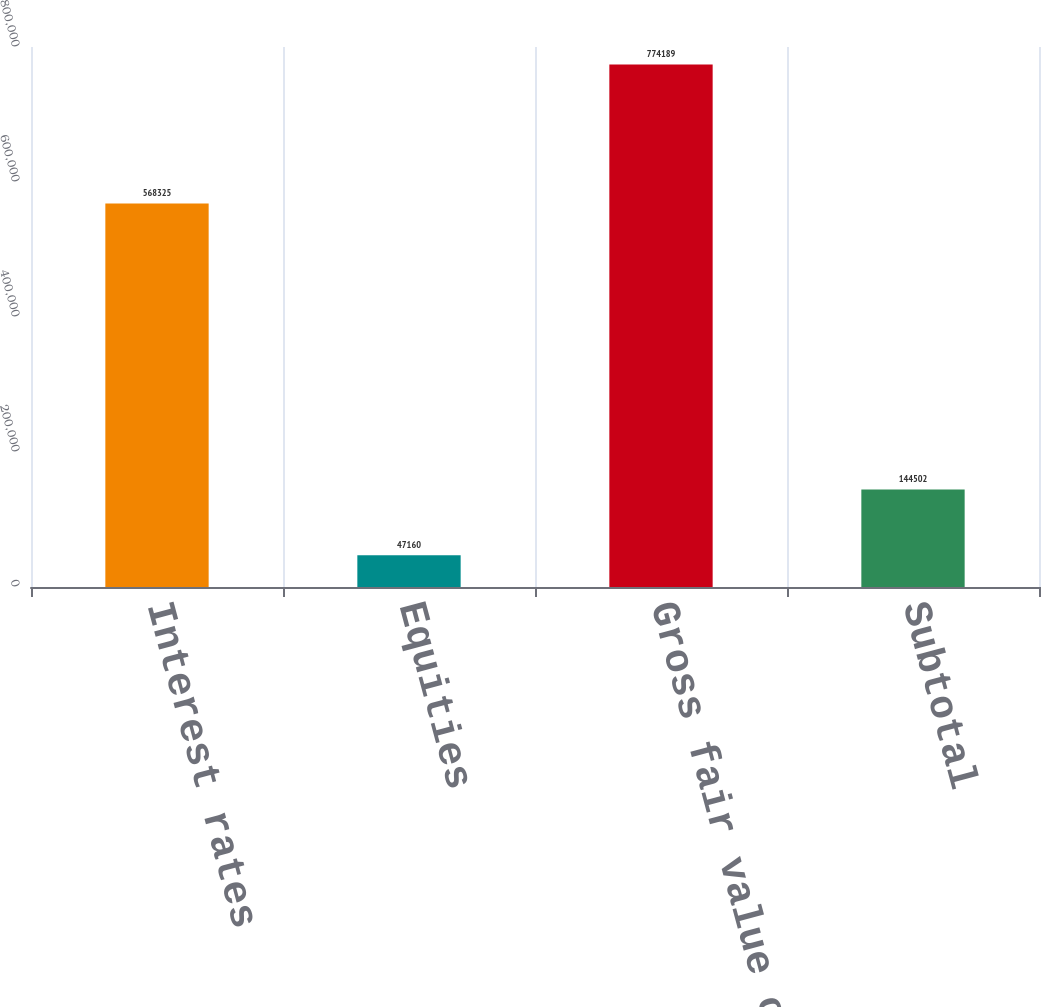Convert chart to OTSL. <chart><loc_0><loc_0><loc_500><loc_500><bar_chart><fcel>Interest rates<fcel>Equities<fcel>Gross fair value of derivative<fcel>Subtotal<nl><fcel>568325<fcel>47160<fcel>774189<fcel>144502<nl></chart> 